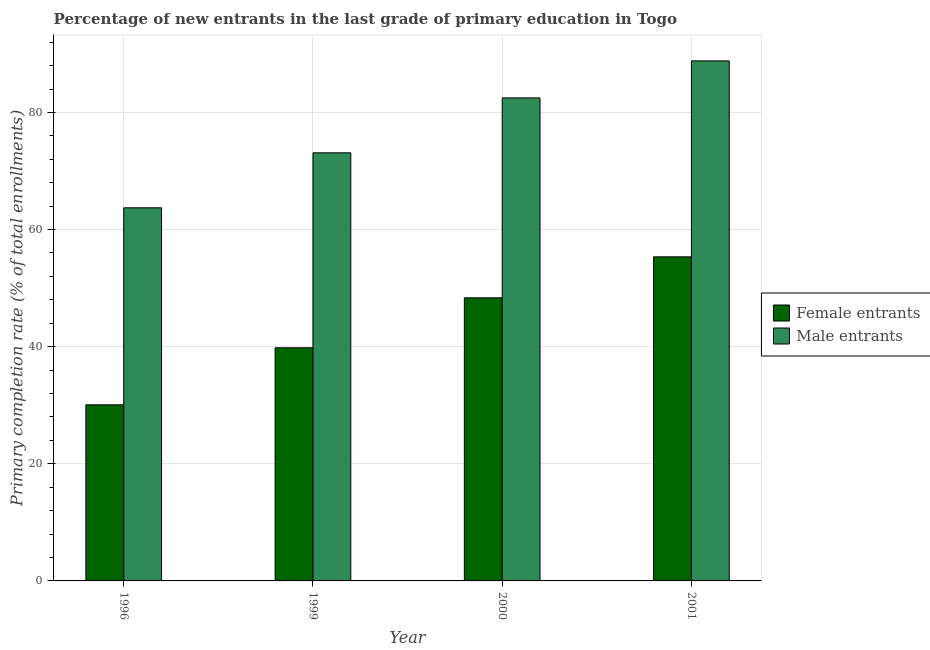Are the number of bars per tick equal to the number of legend labels?
Ensure brevity in your answer.  Yes. Are the number of bars on each tick of the X-axis equal?
Make the answer very short. Yes. How many bars are there on the 4th tick from the left?
Keep it short and to the point. 2. How many bars are there on the 1st tick from the right?
Keep it short and to the point. 2. In how many cases, is the number of bars for a given year not equal to the number of legend labels?
Provide a succinct answer. 0. What is the primary completion rate of male entrants in 2001?
Your response must be concise. 88.81. Across all years, what is the maximum primary completion rate of female entrants?
Your answer should be very brief. 55.34. Across all years, what is the minimum primary completion rate of male entrants?
Provide a short and direct response. 63.72. In which year was the primary completion rate of female entrants maximum?
Offer a terse response. 2001. In which year was the primary completion rate of male entrants minimum?
Give a very brief answer. 1996. What is the total primary completion rate of female entrants in the graph?
Ensure brevity in your answer.  173.57. What is the difference between the primary completion rate of female entrants in 1996 and that in 2000?
Keep it short and to the point. -18.27. What is the difference between the primary completion rate of male entrants in 2000 and the primary completion rate of female entrants in 1999?
Your answer should be very brief. 9.38. What is the average primary completion rate of male entrants per year?
Offer a terse response. 77.03. In how many years, is the primary completion rate of male entrants greater than 24 %?
Keep it short and to the point. 4. What is the ratio of the primary completion rate of female entrants in 1999 to that in 2000?
Provide a short and direct response. 0.82. What is the difference between the highest and the second highest primary completion rate of female entrants?
Make the answer very short. 7. What is the difference between the highest and the lowest primary completion rate of female entrants?
Your answer should be compact. 25.27. In how many years, is the primary completion rate of female entrants greater than the average primary completion rate of female entrants taken over all years?
Provide a succinct answer. 2. What does the 2nd bar from the left in 2001 represents?
Your answer should be compact. Male entrants. What does the 2nd bar from the right in 2001 represents?
Provide a short and direct response. Female entrants. How many bars are there?
Keep it short and to the point. 8. How many years are there in the graph?
Provide a short and direct response. 4. What is the difference between two consecutive major ticks on the Y-axis?
Provide a succinct answer. 20. Are the values on the major ticks of Y-axis written in scientific E-notation?
Provide a succinct answer. No. Does the graph contain any zero values?
Offer a very short reply. No. Where does the legend appear in the graph?
Offer a terse response. Center right. What is the title of the graph?
Your answer should be very brief. Percentage of new entrants in the last grade of primary education in Togo. What is the label or title of the Y-axis?
Provide a succinct answer. Primary completion rate (% of total enrollments). What is the Primary completion rate (% of total enrollments) in Female entrants in 1996?
Offer a very short reply. 30.07. What is the Primary completion rate (% of total enrollments) in Male entrants in 1996?
Your answer should be compact. 63.72. What is the Primary completion rate (% of total enrollments) of Female entrants in 1999?
Keep it short and to the point. 39.81. What is the Primary completion rate (% of total enrollments) in Male entrants in 1999?
Ensure brevity in your answer.  73.11. What is the Primary completion rate (% of total enrollments) in Female entrants in 2000?
Offer a terse response. 48.34. What is the Primary completion rate (% of total enrollments) of Male entrants in 2000?
Your answer should be very brief. 82.49. What is the Primary completion rate (% of total enrollments) in Female entrants in 2001?
Make the answer very short. 55.34. What is the Primary completion rate (% of total enrollments) in Male entrants in 2001?
Keep it short and to the point. 88.81. Across all years, what is the maximum Primary completion rate (% of total enrollments) of Female entrants?
Offer a terse response. 55.34. Across all years, what is the maximum Primary completion rate (% of total enrollments) in Male entrants?
Your response must be concise. 88.81. Across all years, what is the minimum Primary completion rate (% of total enrollments) in Female entrants?
Ensure brevity in your answer.  30.07. Across all years, what is the minimum Primary completion rate (% of total enrollments) of Male entrants?
Offer a terse response. 63.72. What is the total Primary completion rate (% of total enrollments) of Female entrants in the graph?
Your answer should be very brief. 173.57. What is the total Primary completion rate (% of total enrollments) in Male entrants in the graph?
Offer a terse response. 308.12. What is the difference between the Primary completion rate (% of total enrollments) in Female entrants in 1996 and that in 1999?
Keep it short and to the point. -9.74. What is the difference between the Primary completion rate (% of total enrollments) of Male entrants in 1996 and that in 1999?
Keep it short and to the point. -9.39. What is the difference between the Primary completion rate (% of total enrollments) in Female entrants in 1996 and that in 2000?
Provide a succinct answer. -18.27. What is the difference between the Primary completion rate (% of total enrollments) in Male entrants in 1996 and that in 2000?
Give a very brief answer. -18.77. What is the difference between the Primary completion rate (% of total enrollments) in Female entrants in 1996 and that in 2001?
Offer a very short reply. -25.27. What is the difference between the Primary completion rate (% of total enrollments) in Male entrants in 1996 and that in 2001?
Your answer should be very brief. -25.09. What is the difference between the Primary completion rate (% of total enrollments) of Female entrants in 1999 and that in 2000?
Provide a succinct answer. -8.53. What is the difference between the Primary completion rate (% of total enrollments) of Male entrants in 1999 and that in 2000?
Offer a very short reply. -9.38. What is the difference between the Primary completion rate (% of total enrollments) in Female entrants in 1999 and that in 2001?
Make the answer very short. -15.53. What is the difference between the Primary completion rate (% of total enrollments) of Male entrants in 1999 and that in 2001?
Keep it short and to the point. -15.7. What is the difference between the Primary completion rate (% of total enrollments) in Female entrants in 2000 and that in 2001?
Provide a short and direct response. -7. What is the difference between the Primary completion rate (% of total enrollments) of Male entrants in 2000 and that in 2001?
Ensure brevity in your answer.  -6.32. What is the difference between the Primary completion rate (% of total enrollments) in Female entrants in 1996 and the Primary completion rate (% of total enrollments) in Male entrants in 1999?
Give a very brief answer. -43.03. What is the difference between the Primary completion rate (% of total enrollments) of Female entrants in 1996 and the Primary completion rate (% of total enrollments) of Male entrants in 2000?
Ensure brevity in your answer.  -52.41. What is the difference between the Primary completion rate (% of total enrollments) of Female entrants in 1996 and the Primary completion rate (% of total enrollments) of Male entrants in 2001?
Offer a very short reply. -58.74. What is the difference between the Primary completion rate (% of total enrollments) of Female entrants in 1999 and the Primary completion rate (% of total enrollments) of Male entrants in 2000?
Offer a very short reply. -42.68. What is the difference between the Primary completion rate (% of total enrollments) of Female entrants in 1999 and the Primary completion rate (% of total enrollments) of Male entrants in 2001?
Ensure brevity in your answer.  -49. What is the difference between the Primary completion rate (% of total enrollments) of Female entrants in 2000 and the Primary completion rate (% of total enrollments) of Male entrants in 2001?
Provide a short and direct response. -40.47. What is the average Primary completion rate (% of total enrollments) of Female entrants per year?
Offer a terse response. 43.39. What is the average Primary completion rate (% of total enrollments) in Male entrants per year?
Give a very brief answer. 77.03. In the year 1996, what is the difference between the Primary completion rate (% of total enrollments) in Female entrants and Primary completion rate (% of total enrollments) in Male entrants?
Your answer should be very brief. -33.64. In the year 1999, what is the difference between the Primary completion rate (% of total enrollments) of Female entrants and Primary completion rate (% of total enrollments) of Male entrants?
Make the answer very short. -33.3. In the year 2000, what is the difference between the Primary completion rate (% of total enrollments) of Female entrants and Primary completion rate (% of total enrollments) of Male entrants?
Make the answer very short. -34.14. In the year 2001, what is the difference between the Primary completion rate (% of total enrollments) in Female entrants and Primary completion rate (% of total enrollments) in Male entrants?
Offer a very short reply. -33.46. What is the ratio of the Primary completion rate (% of total enrollments) of Female entrants in 1996 to that in 1999?
Keep it short and to the point. 0.76. What is the ratio of the Primary completion rate (% of total enrollments) in Male entrants in 1996 to that in 1999?
Provide a succinct answer. 0.87. What is the ratio of the Primary completion rate (% of total enrollments) of Female entrants in 1996 to that in 2000?
Offer a very short reply. 0.62. What is the ratio of the Primary completion rate (% of total enrollments) in Male entrants in 1996 to that in 2000?
Your response must be concise. 0.77. What is the ratio of the Primary completion rate (% of total enrollments) in Female entrants in 1996 to that in 2001?
Offer a terse response. 0.54. What is the ratio of the Primary completion rate (% of total enrollments) of Male entrants in 1996 to that in 2001?
Provide a short and direct response. 0.72. What is the ratio of the Primary completion rate (% of total enrollments) of Female entrants in 1999 to that in 2000?
Offer a very short reply. 0.82. What is the ratio of the Primary completion rate (% of total enrollments) in Male entrants in 1999 to that in 2000?
Your answer should be very brief. 0.89. What is the ratio of the Primary completion rate (% of total enrollments) of Female entrants in 1999 to that in 2001?
Make the answer very short. 0.72. What is the ratio of the Primary completion rate (% of total enrollments) of Male entrants in 1999 to that in 2001?
Provide a succinct answer. 0.82. What is the ratio of the Primary completion rate (% of total enrollments) in Female entrants in 2000 to that in 2001?
Provide a short and direct response. 0.87. What is the ratio of the Primary completion rate (% of total enrollments) of Male entrants in 2000 to that in 2001?
Provide a succinct answer. 0.93. What is the difference between the highest and the second highest Primary completion rate (% of total enrollments) in Female entrants?
Give a very brief answer. 7. What is the difference between the highest and the second highest Primary completion rate (% of total enrollments) of Male entrants?
Ensure brevity in your answer.  6.32. What is the difference between the highest and the lowest Primary completion rate (% of total enrollments) of Female entrants?
Your response must be concise. 25.27. What is the difference between the highest and the lowest Primary completion rate (% of total enrollments) in Male entrants?
Provide a short and direct response. 25.09. 